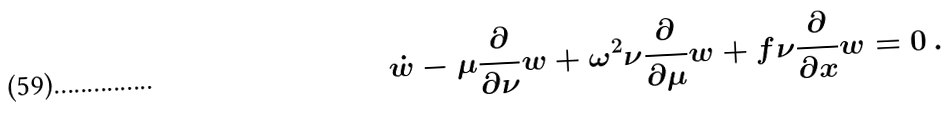Convert formula to latex. <formula><loc_0><loc_0><loc_500><loc_500>\dot { w } - \mu \frac { \partial } { \partial \nu } w + \omega ^ { 2 } \nu \frac { \partial } { \partial \mu } w + f \nu \frac { \partial } { \partial x } w = 0 \, .</formula> 